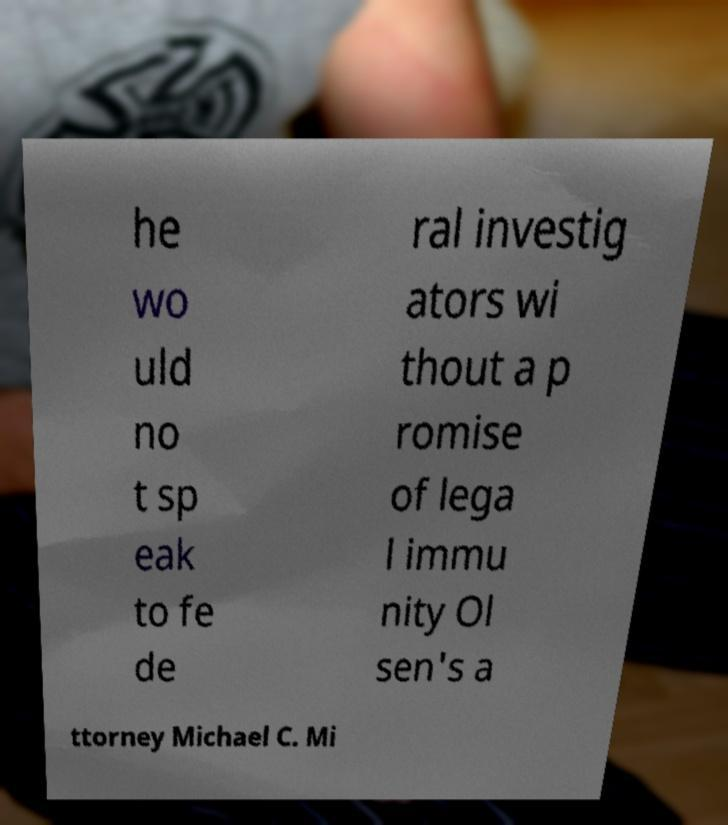Please read and relay the text visible in this image. What does it say? he wo uld no t sp eak to fe de ral investig ators wi thout a p romise of lega l immu nity Ol sen's a ttorney Michael C. Mi 